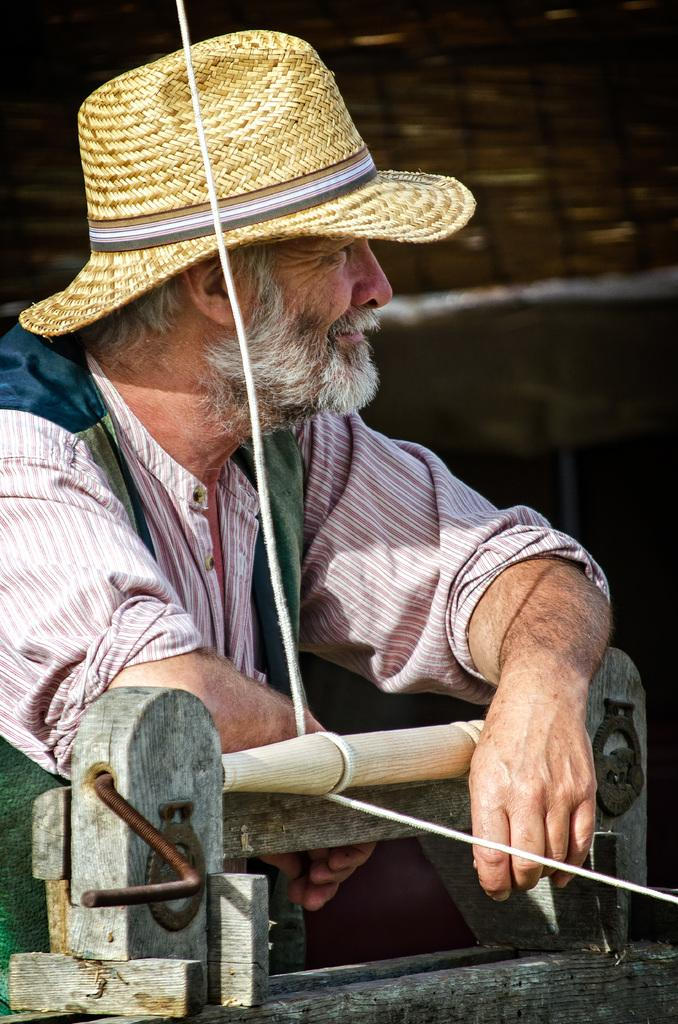Who is present in the image? There is a man in the image. What is the man wearing on his head? The man is wearing a hat. What object can be seen in the image besides the man? There is a device in the image. How is the device connected to something else in the image? The device has a rope attached to it. Where is the man positioned in relation to the device? The man is standing beside the device. What type of zipper can be seen on the man's hat in the image? There is no zipper present on the man's hat in the image. How much debt does the man owe in the image? There is no indication of debt or financial transactions in the image. 